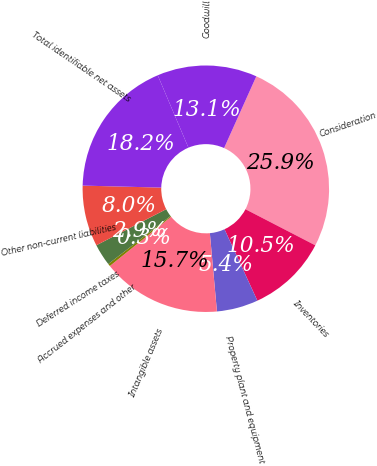Convert chart. <chart><loc_0><loc_0><loc_500><loc_500><pie_chart><fcel>Consideration<fcel>Inventories<fcel>Property plant and equipment<fcel>Intangible assets<fcel>Accrued expenses and other<fcel>Deferred income taxes<fcel>Other non-current liabilities<fcel>Total identifiable net assets<fcel>Goodwill<nl><fcel>25.87%<fcel>10.54%<fcel>5.43%<fcel>15.65%<fcel>0.32%<fcel>2.88%<fcel>7.99%<fcel>18.21%<fcel>13.1%<nl></chart> 